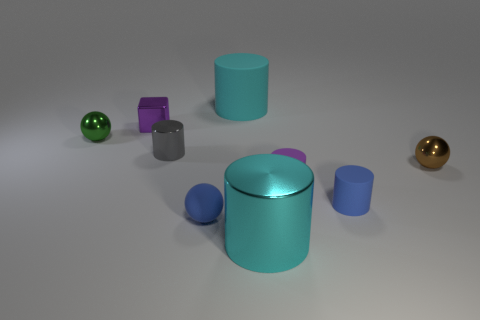There is a matte sphere that is to the right of the green metallic ball; is it the same size as the small blue matte cylinder?
Make the answer very short. Yes. The gray metallic object that is the same shape as the large cyan matte object is what size?
Ensure brevity in your answer.  Small. What is the material of the purple cylinder that is the same size as the gray object?
Provide a succinct answer. Rubber. What material is the tiny green object that is the same shape as the tiny brown object?
Your answer should be very brief. Metal. What number of other objects are the same size as the brown metallic object?
Offer a very short reply. 6. There is a matte thing that is the same color as the block; what is its size?
Give a very brief answer. Small. What number of other shiny blocks have the same color as the small block?
Offer a terse response. 0. The tiny gray thing has what shape?
Your answer should be very brief. Cylinder. There is a shiny thing that is both behind the blue cylinder and in front of the small shiny cylinder; what color is it?
Provide a short and direct response. Brown. What is the material of the green thing?
Provide a short and direct response. Metal. 